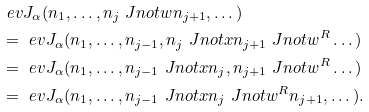<formula> <loc_0><loc_0><loc_500><loc_500>& \ e { v } J _ { \alpha } ( n _ { 1 } , \dots , n _ { j } \ J n o t { w } n _ { j + 1 } , \dots ) \\ & = \ e { v } J _ { \alpha } ( n _ { 1 } , \dots , n _ { j - 1 } , n _ { j } \ J n o t { x } n _ { j + 1 } \ J n o t { w ^ { R } } \dots ) \\ & = \ e { v } J _ { \alpha } ( n _ { 1 } , \dots , n _ { j - 1 } \ J n o t { x } n _ { j } , n _ { j + 1 } \ J n o t { w ^ { R } } \dots ) \\ & = \ e { v } J _ { \alpha } ( n _ { 1 } , \dots , n _ { j - 1 } \ J n o t { x } n _ { j } \ J n o t { w ^ { R } } n _ { j + 1 } , \dots ) .</formula> 